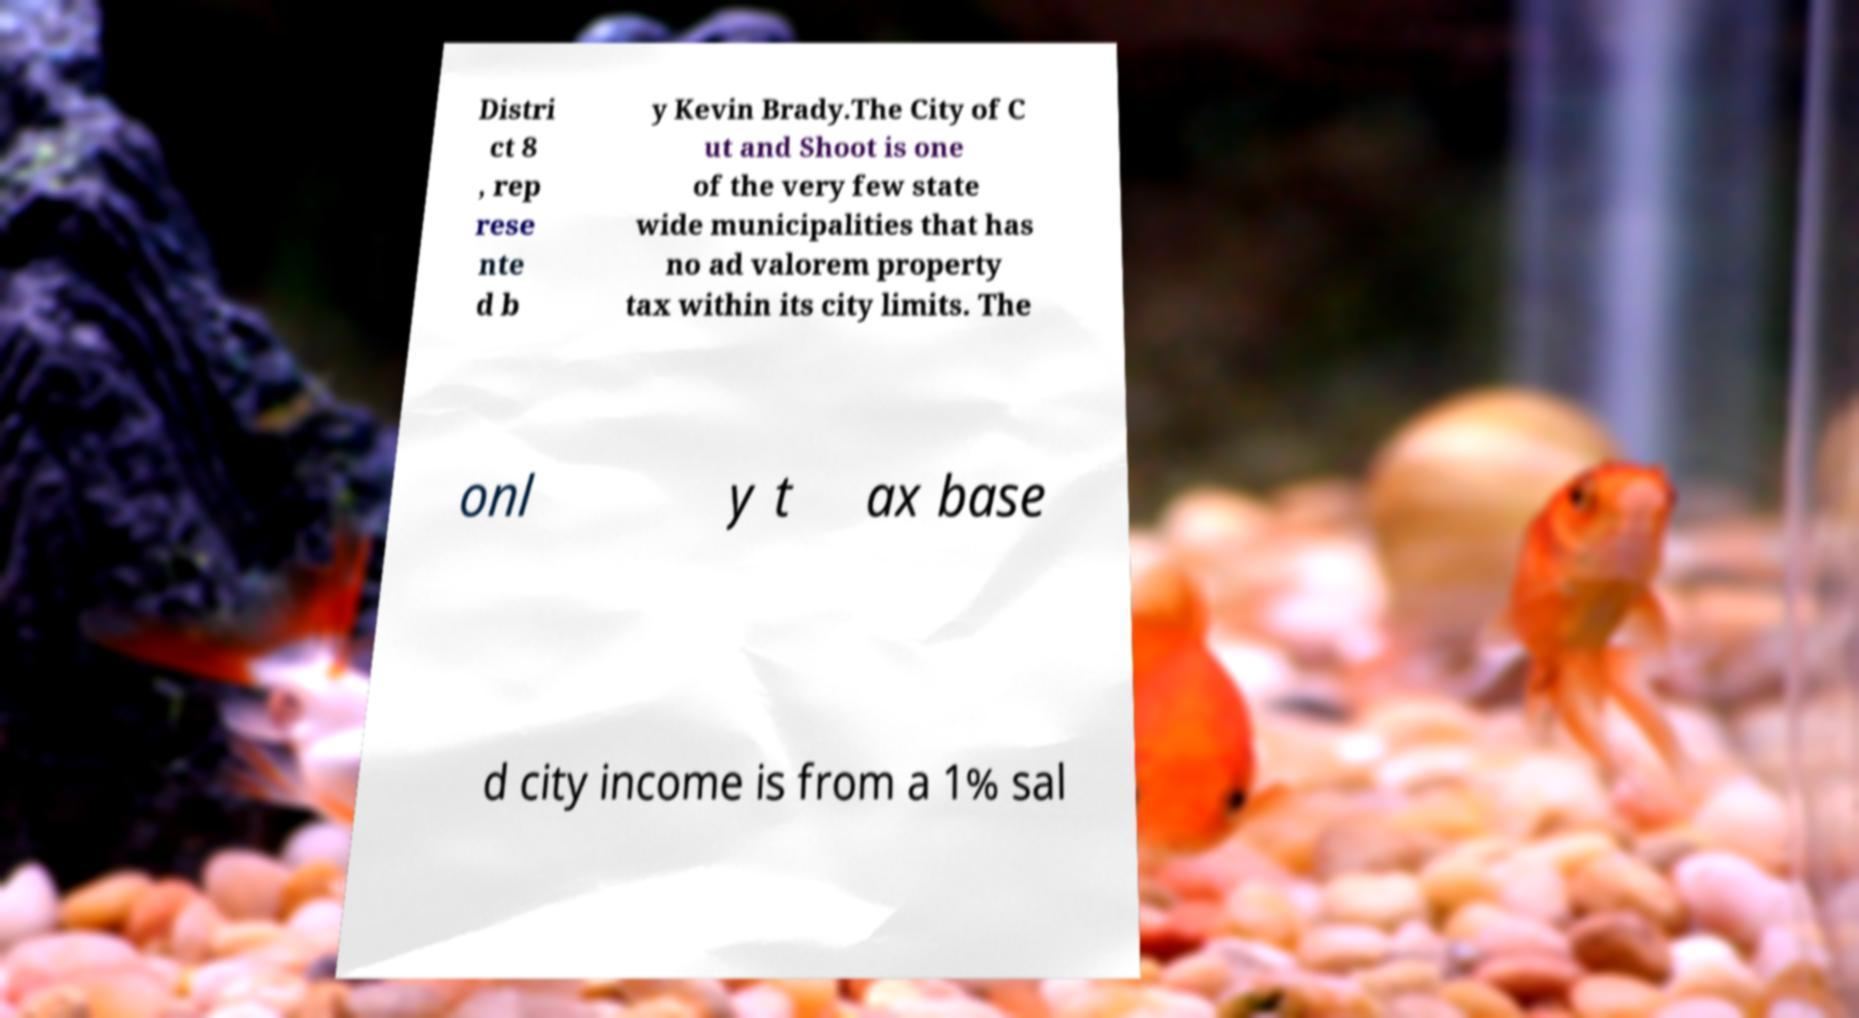Could you extract and type out the text from this image? Distri ct 8 , rep rese nte d b y Kevin Brady.The City of C ut and Shoot is one of the very few state wide municipalities that has no ad valorem property tax within its city limits. The onl y t ax base d city income is from a 1% sal 